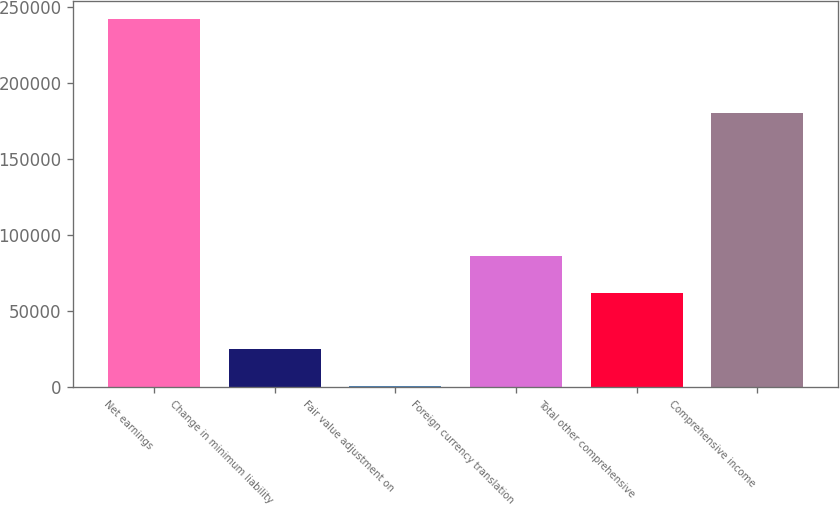Convert chart to OTSL. <chart><loc_0><loc_0><loc_500><loc_500><bar_chart><fcel>Net earnings<fcel>Change in minimum liability<fcel>Fair value adjustment on<fcel>Foreign currency translation<fcel>Total other comprehensive<fcel>Comprehensive income<nl><fcel>241686<fcel>24710.4<fcel>602<fcel>85825.4<fcel>61717<fcel>179969<nl></chart> 